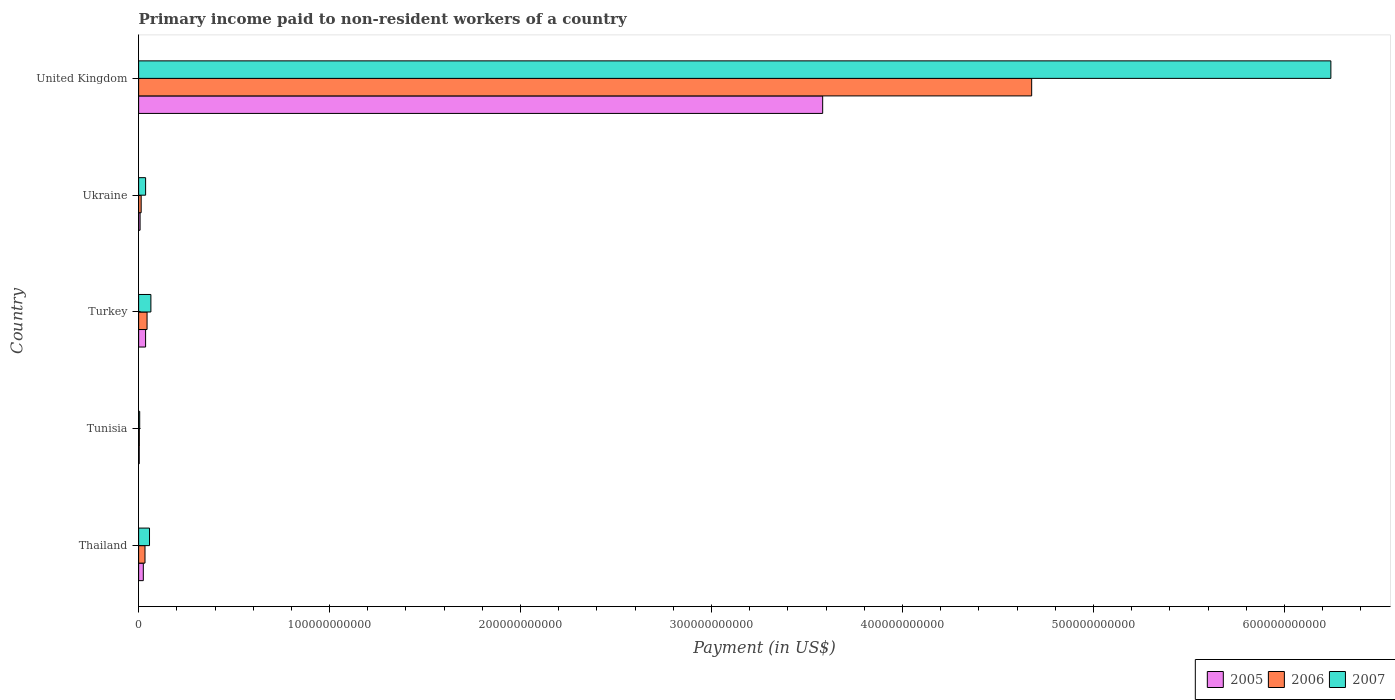Are the number of bars per tick equal to the number of legend labels?
Your answer should be compact. Yes. What is the label of the 2nd group of bars from the top?
Provide a succinct answer. Ukraine. What is the amount paid to workers in 2007 in United Kingdom?
Ensure brevity in your answer.  6.24e+11. Across all countries, what is the maximum amount paid to workers in 2005?
Your answer should be very brief. 3.58e+11. Across all countries, what is the minimum amount paid to workers in 2005?
Offer a terse response. 3.16e+08. In which country was the amount paid to workers in 2005 minimum?
Make the answer very short. Tunisia. What is the total amount paid to workers in 2005 in the graph?
Make the answer very short. 3.65e+11. What is the difference between the amount paid to workers in 2006 in Thailand and that in Tunisia?
Ensure brevity in your answer.  2.97e+09. What is the difference between the amount paid to workers in 2006 in United Kingdom and the amount paid to workers in 2005 in Ukraine?
Offer a very short reply. 4.67e+11. What is the average amount paid to workers in 2006 per country?
Ensure brevity in your answer.  9.54e+1. What is the difference between the amount paid to workers in 2006 and amount paid to workers in 2007 in Thailand?
Your answer should be compact. -2.37e+09. In how many countries, is the amount paid to workers in 2005 greater than 80000000000 US$?
Your answer should be very brief. 1. What is the ratio of the amount paid to workers in 2007 in Turkey to that in United Kingdom?
Provide a succinct answer. 0.01. Is the difference between the amount paid to workers in 2006 in Tunisia and Turkey greater than the difference between the amount paid to workers in 2007 in Tunisia and Turkey?
Keep it short and to the point. Yes. What is the difference between the highest and the second highest amount paid to workers in 2005?
Give a very brief answer. 3.55e+11. What is the difference between the highest and the lowest amount paid to workers in 2005?
Give a very brief answer. 3.58e+11. What does the 2nd bar from the top in United Kingdom represents?
Your answer should be very brief. 2006. What does the 1st bar from the bottom in United Kingdom represents?
Give a very brief answer. 2005. Is it the case that in every country, the sum of the amount paid to workers in 2006 and amount paid to workers in 2007 is greater than the amount paid to workers in 2005?
Keep it short and to the point. Yes. What is the difference between two consecutive major ticks on the X-axis?
Offer a very short reply. 1.00e+11. Does the graph contain any zero values?
Your response must be concise. No. Does the graph contain grids?
Ensure brevity in your answer.  No. Where does the legend appear in the graph?
Offer a very short reply. Bottom right. How are the legend labels stacked?
Your response must be concise. Horizontal. What is the title of the graph?
Ensure brevity in your answer.  Primary income paid to non-resident workers of a country. Does "1962" appear as one of the legend labels in the graph?
Provide a short and direct response. No. What is the label or title of the X-axis?
Make the answer very short. Payment (in US$). What is the Payment (in US$) of 2005 in Thailand?
Ensure brevity in your answer.  2.45e+09. What is the Payment (in US$) of 2006 in Thailand?
Keep it short and to the point. 3.33e+09. What is the Payment (in US$) of 2007 in Thailand?
Provide a short and direct response. 5.70e+09. What is the Payment (in US$) in 2005 in Tunisia?
Your response must be concise. 3.16e+08. What is the Payment (in US$) of 2006 in Tunisia?
Your answer should be very brief. 3.67e+08. What is the Payment (in US$) in 2007 in Tunisia?
Give a very brief answer. 5.63e+08. What is the Payment (in US$) in 2005 in Turkey?
Ensure brevity in your answer.  3.64e+09. What is the Payment (in US$) in 2006 in Turkey?
Make the answer very short. 4.42e+09. What is the Payment (in US$) of 2007 in Turkey?
Make the answer very short. 6.42e+09. What is the Payment (in US$) in 2005 in Ukraine?
Provide a succinct answer. 7.58e+08. What is the Payment (in US$) in 2006 in Ukraine?
Your answer should be compact. 1.33e+09. What is the Payment (in US$) of 2007 in Ukraine?
Provide a short and direct response. 3.66e+09. What is the Payment (in US$) of 2005 in United Kingdom?
Make the answer very short. 3.58e+11. What is the Payment (in US$) in 2006 in United Kingdom?
Make the answer very short. 4.68e+11. What is the Payment (in US$) of 2007 in United Kingdom?
Keep it short and to the point. 6.24e+11. Across all countries, what is the maximum Payment (in US$) of 2005?
Make the answer very short. 3.58e+11. Across all countries, what is the maximum Payment (in US$) in 2006?
Provide a short and direct response. 4.68e+11. Across all countries, what is the maximum Payment (in US$) in 2007?
Your response must be concise. 6.24e+11. Across all countries, what is the minimum Payment (in US$) of 2005?
Offer a terse response. 3.16e+08. Across all countries, what is the minimum Payment (in US$) in 2006?
Provide a short and direct response. 3.67e+08. Across all countries, what is the minimum Payment (in US$) of 2007?
Provide a succinct answer. 5.63e+08. What is the total Payment (in US$) in 2005 in the graph?
Make the answer very short. 3.65e+11. What is the total Payment (in US$) in 2006 in the graph?
Ensure brevity in your answer.  4.77e+11. What is the total Payment (in US$) of 2007 in the graph?
Provide a short and direct response. 6.41e+11. What is the difference between the Payment (in US$) in 2005 in Thailand and that in Tunisia?
Your answer should be compact. 2.14e+09. What is the difference between the Payment (in US$) in 2006 in Thailand and that in Tunisia?
Provide a succinct answer. 2.97e+09. What is the difference between the Payment (in US$) in 2007 in Thailand and that in Tunisia?
Provide a succinct answer. 5.13e+09. What is the difference between the Payment (in US$) of 2005 in Thailand and that in Turkey?
Keep it short and to the point. -1.19e+09. What is the difference between the Payment (in US$) of 2006 in Thailand and that in Turkey?
Give a very brief answer. -1.09e+09. What is the difference between the Payment (in US$) in 2007 in Thailand and that in Turkey?
Make the answer very short. -7.25e+08. What is the difference between the Payment (in US$) of 2005 in Thailand and that in Ukraine?
Provide a short and direct response. 1.69e+09. What is the difference between the Payment (in US$) of 2006 in Thailand and that in Ukraine?
Your answer should be very brief. 2.00e+09. What is the difference between the Payment (in US$) in 2007 in Thailand and that in Ukraine?
Ensure brevity in your answer.  2.04e+09. What is the difference between the Payment (in US$) of 2005 in Thailand and that in United Kingdom?
Your response must be concise. -3.56e+11. What is the difference between the Payment (in US$) in 2006 in Thailand and that in United Kingdom?
Offer a terse response. -4.64e+11. What is the difference between the Payment (in US$) of 2007 in Thailand and that in United Kingdom?
Provide a succinct answer. -6.19e+11. What is the difference between the Payment (in US$) of 2005 in Tunisia and that in Turkey?
Make the answer very short. -3.33e+09. What is the difference between the Payment (in US$) of 2006 in Tunisia and that in Turkey?
Give a very brief answer. -4.05e+09. What is the difference between the Payment (in US$) of 2007 in Tunisia and that in Turkey?
Offer a terse response. -5.86e+09. What is the difference between the Payment (in US$) in 2005 in Tunisia and that in Ukraine?
Your answer should be compact. -4.42e+08. What is the difference between the Payment (in US$) of 2006 in Tunisia and that in Ukraine?
Your answer should be compact. -9.65e+08. What is the difference between the Payment (in US$) in 2007 in Tunisia and that in Ukraine?
Give a very brief answer. -3.09e+09. What is the difference between the Payment (in US$) in 2005 in Tunisia and that in United Kingdom?
Ensure brevity in your answer.  -3.58e+11. What is the difference between the Payment (in US$) of 2006 in Tunisia and that in United Kingdom?
Provide a succinct answer. -4.67e+11. What is the difference between the Payment (in US$) in 2007 in Tunisia and that in United Kingdom?
Your answer should be compact. -6.24e+11. What is the difference between the Payment (in US$) in 2005 in Turkey and that in Ukraine?
Keep it short and to the point. 2.89e+09. What is the difference between the Payment (in US$) of 2006 in Turkey and that in Ukraine?
Provide a succinct answer. 3.09e+09. What is the difference between the Payment (in US$) in 2007 in Turkey and that in Ukraine?
Offer a terse response. 2.77e+09. What is the difference between the Payment (in US$) of 2005 in Turkey and that in United Kingdom?
Ensure brevity in your answer.  -3.55e+11. What is the difference between the Payment (in US$) of 2006 in Turkey and that in United Kingdom?
Offer a terse response. -4.63e+11. What is the difference between the Payment (in US$) in 2007 in Turkey and that in United Kingdom?
Give a very brief answer. -6.18e+11. What is the difference between the Payment (in US$) of 2005 in Ukraine and that in United Kingdom?
Provide a short and direct response. -3.57e+11. What is the difference between the Payment (in US$) of 2006 in Ukraine and that in United Kingdom?
Give a very brief answer. -4.66e+11. What is the difference between the Payment (in US$) of 2007 in Ukraine and that in United Kingdom?
Ensure brevity in your answer.  -6.21e+11. What is the difference between the Payment (in US$) in 2005 in Thailand and the Payment (in US$) in 2006 in Tunisia?
Your answer should be compact. 2.09e+09. What is the difference between the Payment (in US$) of 2005 in Thailand and the Payment (in US$) of 2007 in Tunisia?
Your answer should be very brief. 1.89e+09. What is the difference between the Payment (in US$) in 2006 in Thailand and the Payment (in US$) in 2007 in Tunisia?
Offer a terse response. 2.77e+09. What is the difference between the Payment (in US$) of 2005 in Thailand and the Payment (in US$) of 2006 in Turkey?
Ensure brevity in your answer.  -1.97e+09. What is the difference between the Payment (in US$) in 2005 in Thailand and the Payment (in US$) in 2007 in Turkey?
Your response must be concise. -3.97e+09. What is the difference between the Payment (in US$) of 2006 in Thailand and the Payment (in US$) of 2007 in Turkey?
Keep it short and to the point. -3.09e+09. What is the difference between the Payment (in US$) in 2005 in Thailand and the Payment (in US$) in 2006 in Ukraine?
Ensure brevity in your answer.  1.12e+09. What is the difference between the Payment (in US$) of 2005 in Thailand and the Payment (in US$) of 2007 in Ukraine?
Provide a succinct answer. -1.20e+09. What is the difference between the Payment (in US$) in 2006 in Thailand and the Payment (in US$) in 2007 in Ukraine?
Your answer should be compact. -3.24e+08. What is the difference between the Payment (in US$) of 2005 in Thailand and the Payment (in US$) of 2006 in United Kingdom?
Ensure brevity in your answer.  -4.65e+11. What is the difference between the Payment (in US$) of 2005 in Thailand and the Payment (in US$) of 2007 in United Kingdom?
Provide a succinct answer. -6.22e+11. What is the difference between the Payment (in US$) in 2006 in Thailand and the Payment (in US$) in 2007 in United Kingdom?
Provide a short and direct response. -6.21e+11. What is the difference between the Payment (in US$) of 2005 in Tunisia and the Payment (in US$) of 2006 in Turkey?
Make the answer very short. -4.10e+09. What is the difference between the Payment (in US$) in 2005 in Tunisia and the Payment (in US$) in 2007 in Turkey?
Your answer should be compact. -6.11e+09. What is the difference between the Payment (in US$) in 2006 in Tunisia and the Payment (in US$) in 2007 in Turkey?
Your answer should be very brief. -6.06e+09. What is the difference between the Payment (in US$) of 2005 in Tunisia and the Payment (in US$) of 2006 in Ukraine?
Offer a very short reply. -1.02e+09. What is the difference between the Payment (in US$) of 2005 in Tunisia and the Payment (in US$) of 2007 in Ukraine?
Keep it short and to the point. -3.34e+09. What is the difference between the Payment (in US$) of 2006 in Tunisia and the Payment (in US$) of 2007 in Ukraine?
Make the answer very short. -3.29e+09. What is the difference between the Payment (in US$) in 2005 in Tunisia and the Payment (in US$) in 2006 in United Kingdom?
Your answer should be very brief. -4.67e+11. What is the difference between the Payment (in US$) of 2005 in Tunisia and the Payment (in US$) of 2007 in United Kingdom?
Offer a very short reply. -6.24e+11. What is the difference between the Payment (in US$) of 2006 in Tunisia and the Payment (in US$) of 2007 in United Kingdom?
Your response must be concise. -6.24e+11. What is the difference between the Payment (in US$) in 2005 in Turkey and the Payment (in US$) in 2006 in Ukraine?
Ensure brevity in your answer.  2.31e+09. What is the difference between the Payment (in US$) of 2005 in Turkey and the Payment (in US$) of 2007 in Ukraine?
Your answer should be compact. -1.20e+07. What is the difference between the Payment (in US$) of 2006 in Turkey and the Payment (in US$) of 2007 in Ukraine?
Offer a terse response. 7.62e+08. What is the difference between the Payment (in US$) of 2005 in Turkey and the Payment (in US$) of 2006 in United Kingdom?
Provide a short and direct response. -4.64e+11. What is the difference between the Payment (in US$) in 2005 in Turkey and the Payment (in US$) in 2007 in United Kingdom?
Offer a terse response. -6.21e+11. What is the difference between the Payment (in US$) in 2006 in Turkey and the Payment (in US$) in 2007 in United Kingdom?
Your answer should be very brief. -6.20e+11. What is the difference between the Payment (in US$) of 2005 in Ukraine and the Payment (in US$) of 2006 in United Kingdom?
Offer a terse response. -4.67e+11. What is the difference between the Payment (in US$) of 2005 in Ukraine and the Payment (in US$) of 2007 in United Kingdom?
Provide a succinct answer. -6.24e+11. What is the difference between the Payment (in US$) in 2006 in Ukraine and the Payment (in US$) in 2007 in United Kingdom?
Your answer should be very brief. -6.23e+11. What is the average Payment (in US$) in 2005 per country?
Ensure brevity in your answer.  7.31e+1. What is the average Payment (in US$) of 2006 per country?
Give a very brief answer. 9.54e+1. What is the average Payment (in US$) of 2007 per country?
Provide a short and direct response. 1.28e+11. What is the difference between the Payment (in US$) in 2005 and Payment (in US$) in 2006 in Thailand?
Give a very brief answer. -8.80e+08. What is the difference between the Payment (in US$) in 2005 and Payment (in US$) in 2007 in Thailand?
Your answer should be compact. -3.24e+09. What is the difference between the Payment (in US$) in 2006 and Payment (in US$) in 2007 in Thailand?
Your answer should be compact. -2.37e+09. What is the difference between the Payment (in US$) of 2005 and Payment (in US$) of 2006 in Tunisia?
Offer a very short reply. -5.07e+07. What is the difference between the Payment (in US$) in 2005 and Payment (in US$) in 2007 in Tunisia?
Your response must be concise. -2.47e+08. What is the difference between the Payment (in US$) of 2006 and Payment (in US$) of 2007 in Tunisia?
Your answer should be very brief. -1.96e+08. What is the difference between the Payment (in US$) in 2005 and Payment (in US$) in 2006 in Turkey?
Your response must be concise. -7.74e+08. What is the difference between the Payment (in US$) in 2005 and Payment (in US$) in 2007 in Turkey?
Provide a short and direct response. -2.78e+09. What is the difference between the Payment (in US$) of 2006 and Payment (in US$) of 2007 in Turkey?
Ensure brevity in your answer.  -2.00e+09. What is the difference between the Payment (in US$) of 2005 and Payment (in US$) of 2006 in Ukraine?
Give a very brief answer. -5.74e+08. What is the difference between the Payment (in US$) of 2005 and Payment (in US$) of 2007 in Ukraine?
Offer a terse response. -2.90e+09. What is the difference between the Payment (in US$) of 2006 and Payment (in US$) of 2007 in Ukraine?
Your answer should be compact. -2.32e+09. What is the difference between the Payment (in US$) of 2005 and Payment (in US$) of 2006 in United Kingdom?
Your answer should be very brief. -1.09e+11. What is the difference between the Payment (in US$) of 2005 and Payment (in US$) of 2007 in United Kingdom?
Ensure brevity in your answer.  -2.66e+11. What is the difference between the Payment (in US$) in 2006 and Payment (in US$) in 2007 in United Kingdom?
Provide a short and direct response. -1.57e+11. What is the ratio of the Payment (in US$) in 2005 in Thailand to that in Tunisia?
Ensure brevity in your answer.  7.77. What is the ratio of the Payment (in US$) in 2006 in Thailand to that in Tunisia?
Give a very brief answer. 9.09. What is the ratio of the Payment (in US$) in 2007 in Thailand to that in Tunisia?
Your response must be concise. 10.13. What is the ratio of the Payment (in US$) in 2005 in Thailand to that in Turkey?
Keep it short and to the point. 0.67. What is the ratio of the Payment (in US$) in 2006 in Thailand to that in Turkey?
Your answer should be compact. 0.75. What is the ratio of the Payment (in US$) of 2007 in Thailand to that in Turkey?
Give a very brief answer. 0.89. What is the ratio of the Payment (in US$) in 2005 in Thailand to that in Ukraine?
Ensure brevity in your answer.  3.24. What is the ratio of the Payment (in US$) of 2006 in Thailand to that in Ukraine?
Keep it short and to the point. 2.5. What is the ratio of the Payment (in US$) in 2007 in Thailand to that in Ukraine?
Your response must be concise. 1.56. What is the ratio of the Payment (in US$) of 2005 in Thailand to that in United Kingdom?
Offer a very short reply. 0.01. What is the ratio of the Payment (in US$) of 2006 in Thailand to that in United Kingdom?
Give a very brief answer. 0.01. What is the ratio of the Payment (in US$) of 2007 in Thailand to that in United Kingdom?
Your answer should be compact. 0.01. What is the ratio of the Payment (in US$) of 2005 in Tunisia to that in Turkey?
Make the answer very short. 0.09. What is the ratio of the Payment (in US$) in 2006 in Tunisia to that in Turkey?
Give a very brief answer. 0.08. What is the ratio of the Payment (in US$) in 2007 in Tunisia to that in Turkey?
Provide a succinct answer. 0.09. What is the ratio of the Payment (in US$) of 2005 in Tunisia to that in Ukraine?
Provide a short and direct response. 0.42. What is the ratio of the Payment (in US$) in 2006 in Tunisia to that in Ukraine?
Give a very brief answer. 0.28. What is the ratio of the Payment (in US$) in 2007 in Tunisia to that in Ukraine?
Keep it short and to the point. 0.15. What is the ratio of the Payment (in US$) of 2005 in Tunisia to that in United Kingdom?
Give a very brief answer. 0. What is the ratio of the Payment (in US$) of 2006 in Tunisia to that in United Kingdom?
Provide a succinct answer. 0. What is the ratio of the Payment (in US$) of 2007 in Tunisia to that in United Kingdom?
Ensure brevity in your answer.  0. What is the ratio of the Payment (in US$) in 2005 in Turkey to that in Ukraine?
Your answer should be compact. 4.81. What is the ratio of the Payment (in US$) in 2006 in Turkey to that in Ukraine?
Provide a short and direct response. 3.32. What is the ratio of the Payment (in US$) in 2007 in Turkey to that in Ukraine?
Your response must be concise. 1.76. What is the ratio of the Payment (in US$) of 2005 in Turkey to that in United Kingdom?
Give a very brief answer. 0.01. What is the ratio of the Payment (in US$) in 2006 in Turkey to that in United Kingdom?
Offer a very short reply. 0.01. What is the ratio of the Payment (in US$) in 2007 in Turkey to that in United Kingdom?
Your answer should be compact. 0.01. What is the ratio of the Payment (in US$) in 2005 in Ukraine to that in United Kingdom?
Your answer should be very brief. 0. What is the ratio of the Payment (in US$) in 2006 in Ukraine to that in United Kingdom?
Make the answer very short. 0. What is the ratio of the Payment (in US$) in 2007 in Ukraine to that in United Kingdom?
Provide a short and direct response. 0.01. What is the difference between the highest and the second highest Payment (in US$) of 2005?
Give a very brief answer. 3.55e+11. What is the difference between the highest and the second highest Payment (in US$) of 2006?
Ensure brevity in your answer.  4.63e+11. What is the difference between the highest and the second highest Payment (in US$) in 2007?
Make the answer very short. 6.18e+11. What is the difference between the highest and the lowest Payment (in US$) of 2005?
Give a very brief answer. 3.58e+11. What is the difference between the highest and the lowest Payment (in US$) of 2006?
Keep it short and to the point. 4.67e+11. What is the difference between the highest and the lowest Payment (in US$) of 2007?
Make the answer very short. 6.24e+11. 